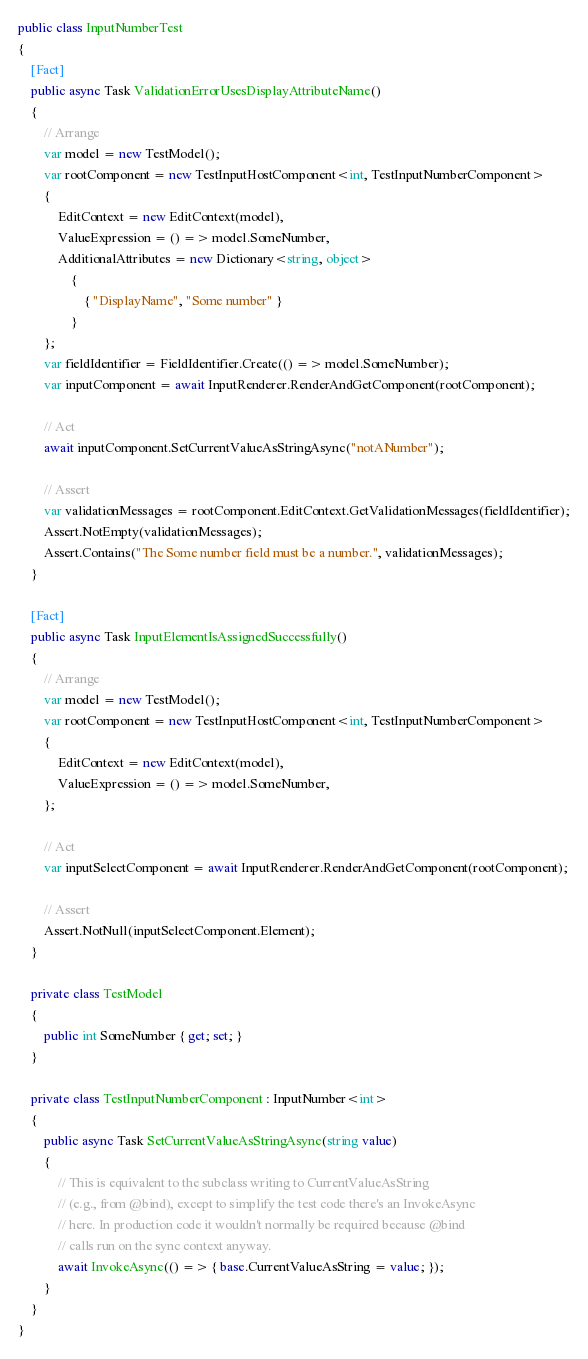<code> <loc_0><loc_0><loc_500><loc_500><_C#_>
public class InputNumberTest
{
    [Fact]
    public async Task ValidationErrorUsesDisplayAttributeName()
    {
        // Arrange
        var model = new TestModel();
        var rootComponent = new TestInputHostComponent<int, TestInputNumberComponent>
        {
            EditContext = new EditContext(model),
            ValueExpression = () => model.SomeNumber,
            AdditionalAttributes = new Dictionary<string, object>
                {
                    { "DisplayName", "Some number" }
                }
        };
        var fieldIdentifier = FieldIdentifier.Create(() => model.SomeNumber);
        var inputComponent = await InputRenderer.RenderAndGetComponent(rootComponent);

        // Act
        await inputComponent.SetCurrentValueAsStringAsync("notANumber");

        // Assert
        var validationMessages = rootComponent.EditContext.GetValidationMessages(fieldIdentifier);
        Assert.NotEmpty(validationMessages);
        Assert.Contains("The Some number field must be a number.", validationMessages);
    }

    [Fact]
    public async Task InputElementIsAssignedSuccessfully()
    {
        // Arrange
        var model = new TestModel();
        var rootComponent = new TestInputHostComponent<int, TestInputNumberComponent>
        {
            EditContext = new EditContext(model),
            ValueExpression = () => model.SomeNumber,
        };

        // Act
        var inputSelectComponent = await InputRenderer.RenderAndGetComponent(rootComponent);

        // Assert
        Assert.NotNull(inputSelectComponent.Element);
    }

    private class TestModel
    {
        public int SomeNumber { get; set; }
    }

    private class TestInputNumberComponent : InputNumber<int>
    {
        public async Task SetCurrentValueAsStringAsync(string value)
        {
            // This is equivalent to the subclass writing to CurrentValueAsString
            // (e.g., from @bind), except to simplify the test code there's an InvokeAsync
            // here. In production code it wouldn't normally be required because @bind
            // calls run on the sync context anyway.
            await InvokeAsync(() => { base.CurrentValueAsString = value; });
        }
    }
}
</code> 